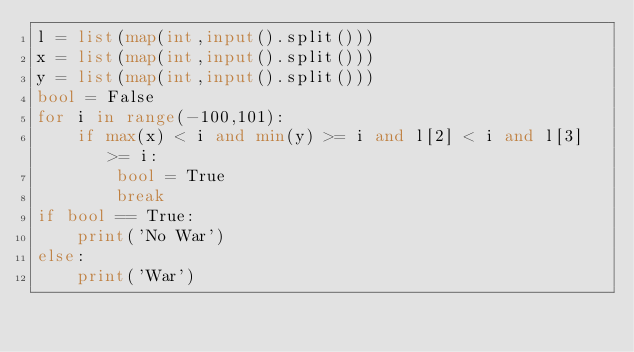<code> <loc_0><loc_0><loc_500><loc_500><_Python_>l = list(map(int,input().split()))
x = list(map(int,input().split()))
y = list(map(int,input().split()))
bool = False
for i in range(-100,101):
    if max(x) < i and min(y) >= i and l[2] < i and l[3] >= i:
        bool = True
        break
if bool == True:
    print('No War')
else:
    print('War')
</code> 